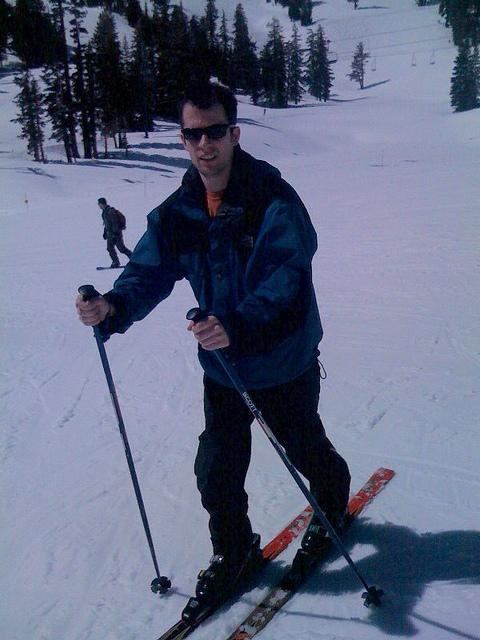What is the man in the foreground balancing with?

Choices:
A) ski poles
B) bannister
C) rope
D) hook ski poles 